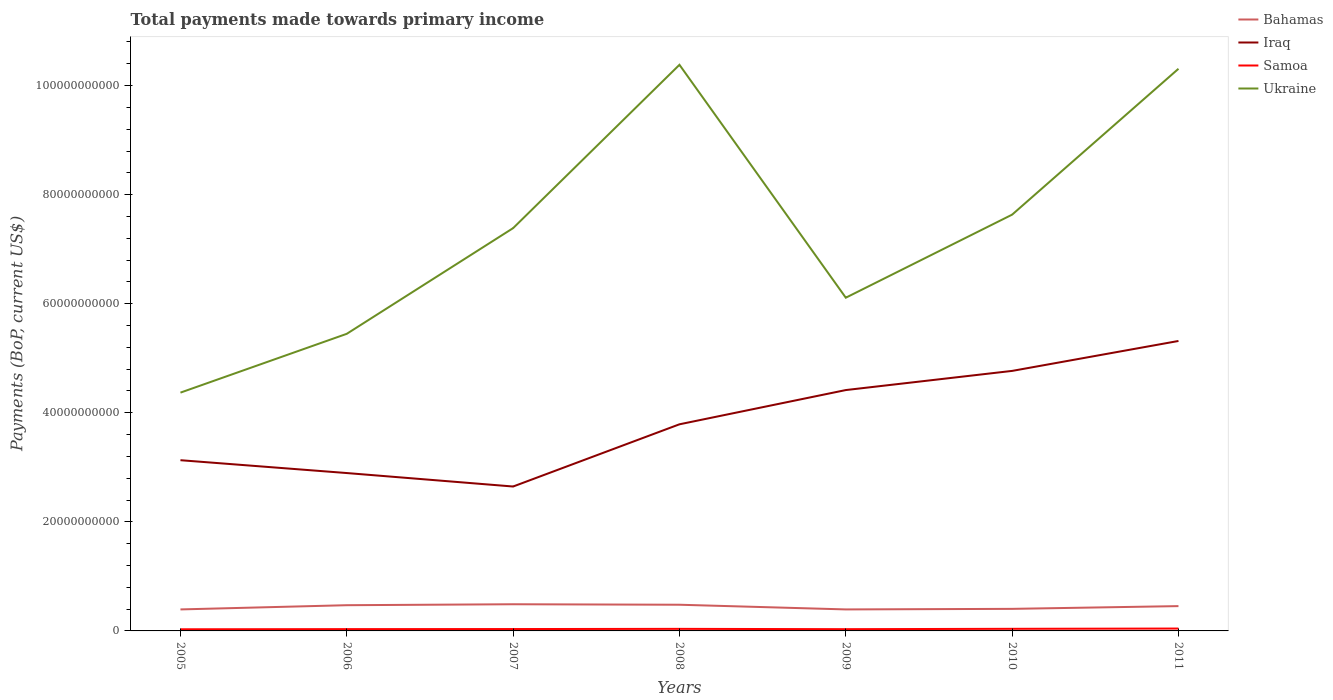Across all years, what is the maximum total payments made towards primary income in Bahamas?
Offer a terse response. 3.94e+09. In which year was the total payments made towards primary income in Iraq maximum?
Offer a very short reply. 2007. What is the total total payments made towards primary income in Bahamas in the graph?
Your answer should be compact. 9.48e+08. What is the difference between the highest and the second highest total payments made towards primary income in Samoa?
Make the answer very short. 1.34e+08. Is the total payments made towards primary income in Iraq strictly greater than the total payments made towards primary income in Samoa over the years?
Keep it short and to the point. No. How many lines are there?
Give a very brief answer. 4. How many years are there in the graph?
Your answer should be compact. 7. What is the difference between two consecutive major ticks on the Y-axis?
Make the answer very short. 2.00e+1. Are the values on the major ticks of Y-axis written in scientific E-notation?
Ensure brevity in your answer.  No. Does the graph contain grids?
Make the answer very short. No. What is the title of the graph?
Keep it short and to the point. Total payments made towards primary income. What is the label or title of the X-axis?
Make the answer very short. Years. What is the label or title of the Y-axis?
Your answer should be very brief. Payments (BoP, current US$). What is the Payments (BoP, current US$) in Bahamas in 2005?
Make the answer very short. 3.94e+09. What is the Payments (BoP, current US$) in Iraq in 2005?
Provide a short and direct response. 3.13e+1. What is the Payments (BoP, current US$) of Samoa in 2005?
Give a very brief answer. 3.00e+08. What is the Payments (BoP, current US$) in Ukraine in 2005?
Your response must be concise. 4.37e+1. What is the Payments (BoP, current US$) of Bahamas in 2006?
Offer a terse response. 4.71e+09. What is the Payments (BoP, current US$) of Iraq in 2006?
Your response must be concise. 2.89e+1. What is the Payments (BoP, current US$) in Samoa in 2006?
Offer a terse response. 3.29e+08. What is the Payments (BoP, current US$) in Ukraine in 2006?
Offer a very short reply. 5.45e+1. What is the Payments (BoP, current US$) in Bahamas in 2007?
Offer a very short reply. 4.89e+09. What is the Payments (BoP, current US$) in Iraq in 2007?
Ensure brevity in your answer.  2.65e+1. What is the Payments (BoP, current US$) of Samoa in 2007?
Your response must be concise. 3.44e+08. What is the Payments (BoP, current US$) in Ukraine in 2007?
Offer a very short reply. 7.39e+1. What is the Payments (BoP, current US$) in Bahamas in 2008?
Make the answer very short. 4.80e+09. What is the Payments (BoP, current US$) of Iraq in 2008?
Your answer should be very brief. 3.79e+1. What is the Payments (BoP, current US$) of Samoa in 2008?
Make the answer very short. 3.77e+08. What is the Payments (BoP, current US$) in Ukraine in 2008?
Keep it short and to the point. 1.04e+11. What is the Payments (BoP, current US$) in Bahamas in 2009?
Provide a short and direct response. 3.94e+09. What is the Payments (BoP, current US$) in Iraq in 2009?
Your answer should be compact. 4.42e+1. What is the Payments (BoP, current US$) in Samoa in 2009?
Keep it short and to the point. 3.20e+08. What is the Payments (BoP, current US$) in Ukraine in 2009?
Provide a succinct answer. 6.11e+1. What is the Payments (BoP, current US$) in Bahamas in 2010?
Your answer should be compact. 4.05e+09. What is the Payments (BoP, current US$) in Iraq in 2010?
Your response must be concise. 4.77e+1. What is the Payments (BoP, current US$) in Samoa in 2010?
Your answer should be compact. 3.86e+08. What is the Payments (BoP, current US$) in Ukraine in 2010?
Offer a very short reply. 7.63e+1. What is the Payments (BoP, current US$) in Bahamas in 2011?
Offer a very short reply. 4.55e+09. What is the Payments (BoP, current US$) in Iraq in 2011?
Offer a terse response. 5.32e+1. What is the Payments (BoP, current US$) in Samoa in 2011?
Ensure brevity in your answer.  4.34e+08. What is the Payments (BoP, current US$) of Ukraine in 2011?
Make the answer very short. 1.03e+11. Across all years, what is the maximum Payments (BoP, current US$) of Bahamas?
Provide a short and direct response. 4.89e+09. Across all years, what is the maximum Payments (BoP, current US$) in Iraq?
Your answer should be compact. 5.32e+1. Across all years, what is the maximum Payments (BoP, current US$) of Samoa?
Your response must be concise. 4.34e+08. Across all years, what is the maximum Payments (BoP, current US$) of Ukraine?
Offer a very short reply. 1.04e+11. Across all years, what is the minimum Payments (BoP, current US$) of Bahamas?
Make the answer very short. 3.94e+09. Across all years, what is the minimum Payments (BoP, current US$) of Iraq?
Your answer should be very brief. 2.65e+1. Across all years, what is the minimum Payments (BoP, current US$) of Samoa?
Provide a succinct answer. 3.00e+08. Across all years, what is the minimum Payments (BoP, current US$) of Ukraine?
Provide a short and direct response. 4.37e+1. What is the total Payments (BoP, current US$) of Bahamas in the graph?
Offer a very short reply. 3.09e+1. What is the total Payments (BoP, current US$) of Iraq in the graph?
Your response must be concise. 2.70e+11. What is the total Payments (BoP, current US$) in Samoa in the graph?
Ensure brevity in your answer.  2.49e+09. What is the total Payments (BoP, current US$) of Ukraine in the graph?
Ensure brevity in your answer.  5.16e+11. What is the difference between the Payments (BoP, current US$) of Bahamas in 2005 and that in 2006?
Make the answer very short. -7.72e+08. What is the difference between the Payments (BoP, current US$) of Iraq in 2005 and that in 2006?
Offer a very short reply. 2.36e+09. What is the difference between the Payments (BoP, current US$) of Samoa in 2005 and that in 2006?
Give a very brief answer. -2.86e+07. What is the difference between the Payments (BoP, current US$) of Ukraine in 2005 and that in 2006?
Ensure brevity in your answer.  -1.08e+1. What is the difference between the Payments (BoP, current US$) in Bahamas in 2005 and that in 2007?
Your answer should be very brief. -9.46e+08. What is the difference between the Payments (BoP, current US$) in Iraq in 2005 and that in 2007?
Provide a succinct answer. 4.83e+09. What is the difference between the Payments (BoP, current US$) in Samoa in 2005 and that in 2007?
Offer a terse response. -4.42e+07. What is the difference between the Payments (BoP, current US$) in Ukraine in 2005 and that in 2007?
Provide a short and direct response. -3.02e+1. What is the difference between the Payments (BoP, current US$) of Bahamas in 2005 and that in 2008?
Your response must be concise. -8.58e+08. What is the difference between the Payments (BoP, current US$) of Iraq in 2005 and that in 2008?
Provide a short and direct response. -6.58e+09. What is the difference between the Payments (BoP, current US$) in Samoa in 2005 and that in 2008?
Offer a very short reply. -7.67e+07. What is the difference between the Payments (BoP, current US$) in Ukraine in 2005 and that in 2008?
Keep it short and to the point. -6.01e+1. What is the difference between the Payments (BoP, current US$) in Bahamas in 2005 and that in 2009?
Your answer should be compact. 1.18e+06. What is the difference between the Payments (BoP, current US$) in Iraq in 2005 and that in 2009?
Offer a very short reply. -1.29e+1. What is the difference between the Payments (BoP, current US$) in Samoa in 2005 and that in 2009?
Your answer should be compact. -1.96e+07. What is the difference between the Payments (BoP, current US$) in Ukraine in 2005 and that in 2009?
Provide a short and direct response. -1.74e+1. What is the difference between the Payments (BoP, current US$) of Bahamas in 2005 and that in 2010?
Make the answer very short. -1.03e+08. What is the difference between the Payments (BoP, current US$) of Iraq in 2005 and that in 2010?
Give a very brief answer. -1.64e+1. What is the difference between the Payments (BoP, current US$) in Samoa in 2005 and that in 2010?
Your answer should be very brief. -8.62e+07. What is the difference between the Payments (BoP, current US$) of Ukraine in 2005 and that in 2010?
Your answer should be compact. -3.26e+1. What is the difference between the Payments (BoP, current US$) in Bahamas in 2005 and that in 2011?
Offer a very short reply. -6.07e+08. What is the difference between the Payments (BoP, current US$) in Iraq in 2005 and that in 2011?
Offer a terse response. -2.19e+1. What is the difference between the Payments (BoP, current US$) in Samoa in 2005 and that in 2011?
Your response must be concise. -1.34e+08. What is the difference between the Payments (BoP, current US$) of Ukraine in 2005 and that in 2011?
Offer a terse response. -5.94e+1. What is the difference between the Payments (BoP, current US$) of Bahamas in 2006 and that in 2007?
Offer a very short reply. -1.75e+08. What is the difference between the Payments (BoP, current US$) of Iraq in 2006 and that in 2007?
Give a very brief answer. 2.47e+09. What is the difference between the Payments (BoP, current US$) in Samoa in 2006 and that in 2007?
Your answer should be compact. -1.56e+07. What is the difference between the Payments (BoP, current US$) of Ukraine in 2006 and that in 2007?
Your response must be concise. -1.94e+1. What is the difference between the Payments (BoP, current US$) of Bahamas in 2006 and that in 2008?
Ensure brevity in your answer.  -8.58e+07. What is the difference between the Payments (BoP, current US$) of Iraq in 2006 and that in 2008?
Keep it short and to the point. -8.94e+09. What is the difference between the Payments (BoP, current US$) of Samoa in 2006 and that in 2008?
Make the answer very short. -4.81e+07. What is the difference between the Payments (BoP, current US$) of Ukraine in 2006 and that in 2008?
Provide a short and direct response. -4.93e+1. What is the difference between the Payments (BoP, current US$) in Bahamas in 2006 and that in 2009?
Keep it short and to the point. 7.73e+08. What is the difference between the Payments (BoP, current US$) in Iraq in 2006 and that in 2009?
Give a very brief answer. -1.52e+1. What is the difference between the Payments (BoP, current US$) in Samoa in 2006 and that in 2009?
Give a very brief answer. 8.97e+06. What is the difference between the Payments (BoP, current US$) of Ukraine in 2006 and that in 2009?
Your answer should be very brief. -6.62e+09. What is the difference between the Payments (BoP, current US$) in Bahamas in 2006 and that in 2010?
Provide a succinct answer. 6.69e+08. What is the difference between the Payments (BoP, current US$) in Iraq in 2006 and that in 2010?
Your response must be concise. -1.87e+1. What is the difference between the Payments (BoP, current US$) of Samoa in 2006 and that in 2010?
Give a very brief answer. -5.76e+07. What is the difference between the Payments (BoP, current US$) in Ukraine in 2006 and that in 2010?
Offer a very short reply. -2.19e+1. What is the difference between the Payments (BoP, current US$) in Bahamas in 2006 and that in 2011?
Your answer should be very brief. 1.65e+08. What is the difference between the Payments (BoP, current US$) in Iraq in 2006 and that in 2011?
Your answer should be very brief. -2.42e+1. What is the difference between the Payments (BoP, current US$) of Samoa in 2006 and that in 2011?
Ensure brevity in your answer.  -1.05e+08. What is the difference between the Payments (BoP, current US$) of Ukraine in 2006 and that in 2011?
Keep it short and to the point. -4.86e+1. What is the difference between the Payments (BoP, current US$) in Bahamas in 2007 and that in 2008?
Provide a succinct answer. 8.88e+07. What is the difference between the Payments (BoP, current US$) in Iraq in 2007 and that in 2008?
Your answer should be compact. -1.14e+1. What is the difference between the Payments (BoP, current US$) in Samoa in 2007 and that in 2008?
Your answer should be very brief. -3.25e+07. What is the difference between the Payments (BoP, current US$) of Ukraine in 2007 and that in 2008?
Keep it short and to the point. -2.99e+1. What is the difference between the Payments (BoP, current US$) in Bahamas in 2007 and that in 2009?
Provide a short and direct response. 9.48e+08. What is the difference between the Payments (BoP, current US$) of Iraq in 2007 and that in 2009?
Your answer should be compact. -1.77e+1. What is the difference between the Payments (BoP, current US$) of Samoa in 2007 and that in 2009?
Your answer should be very brief. 2.46e+07. What is the difference between the Payments (BoP, current US$) in Ukraine in 2007 and that in 2009?
Offer a terse response. 1.28e+1. What is the difference between the Payments (BoP, current US$) of Bahamas in 2007 and that in 2010?
Make the answer very short. 8.43e+08. What is the difference between the Payments (BoP, current US$) in Iraq in 2007 and that in 2010?
Make the answer very short. -2.12e+1. What is the difference between the Payments (BoP, current US$) of Samoa in 2007 and that in 2010?
Offer a very short reply. -4.20e+07. What is the difference between the Payments (BoP, current US$) in Ukraine in 2007 and that in 2010?
Keep it short and to the point. -2.47e+09. What is the difference between the Payments (BoP, current US$) of Bahamas in 2007 and that in 2011?
Offer a very short reply. 3.40e+08. What is the difference between the Payments (BoP, current US$) of Iraq in 2007 and that in 2011?
Your answer should be very brief. -2.67e+1. What is the difference between the Payments (BoP, current US$) of Samoa in 2007 and that in 2011?
Provide a succinct answer. -8.98e+07. What is the difference between the Payments (BoP, current US$) in Ukraine in 2007 and that in 2011?
Keep it short and to the point. -2.92e+1. What is the difference between the Payments (BoP, current US$) of Bahamas in 2008 and that in 2009?
Offer a terse response. 8.59e+08. What is the difference between the Payments (BoP, current US$) of Iraq in 2008 and that in 2009?
Your response must be concise. -6.28e+09. What is the difference between the Payments (BoP, current US$) in Samoa in 2008 and that in 2009?
Your answer should be very brief. 5.70e+07. What is the difference between the Payments (BoP, current US$) of Ukraine in 2008 and that in 2009?
Your answer should be very brief. 4.27e+1. What is the difference between the Payments (BoP, current US$) in Bahamas in 2008 and that in 2010?
Give a very brief answer. 7.54e+08. What is the difference between the Payments (BoP, current US$) in Iraq in 2008 and that in 2010?
Make the answer very short. -9.79e+09. What is the difference between the Payments (BoP, current US$) in Samoa in 2008 and that in 2010?
Your answer should be compact. -9.55e+06. What is the difference between the Payments (BoP, current US$) in Ukraine in 2008 and that in 2010?
Keep it short and to the point. 2.75e+1. What is the difference between the Payments (BoP, current US$) of Bahamas in 2008 and that in 2011?
Provide a succinct answer. 2.51e+08. What is the difference between the Payments (BoP, current US$) of Iraq in 2008 and that in 2011?
Provide a short and direct response. -1.53e+1. What is the difference between the Payments (BoP, current US$) of Samoa in 2008 and that in 2011?
Your response must be concise. -5.74e+07. What is the difference between the Payments (BoP, current US$) of Ukraine in 2008 and that in 2011?
Offer a very short reply. 7.29e+08. What is the difference between the Payments (BoP, current US$) of Bahamas in 2009 and that in 2010?
Give a very brief answer. -1.05e+08. What is the difference between the Payments (BoP, current US$) of Iraq in 2009 and that in 2010?
Your response must be concise. -3.51e+09. What is the difference between the Payments (BoP, current US$) of Samoa in 2009 and that in 2010?
Your answer should be very brief. -6.66e+07. What is the difference between the Payments (BoP, current US$) of Ukraine in 2009 and that in 2010?
Your response must be concise. -1.52e+1. What is the difference between the Payments (BoP, current US$) of Bahamas in 2009 and that in 2011?
Make the answer very short. -6.08e+08. What is the difference between the Payments (BoP, current US$) in Iraq in 2009 and that in 2011?
Offer a very short reply. -9.00e+09. What is the difference between the Payments (BoP, current US$) of Samoa in 2009 and that in 2011?
Give a very brief answer. -1.14e+08. What is the difference between the Payments (BoP, current US$) of Ukraine in 2009 and that in 2011?
Offer a terse response. -4.20e+1. What is the difference between the Payments (BoP, current US$) in Bahamas in 2010 and that in 2011?
Keep it short and to the point. -5.03e+08. What is the difference between the Payments (BoP, current US$) in Iraq in 2010 and that in 2011?
Provide a succinct answer. -5.49e+09. What is the difference between the Payments (BoP, current US$) in Samoa in 2010 and that in 2011?
Your answer should be compact. -4.78e+07. What is the difference between the Payments (BoP, current US$) in Ukraine in 2010 and that in 2011?
Offer a very short reply. -2.67e+1. What is the difference between the Payments (BoP, current US$) of Bahamas in 2005 and the Payments (BoP, current US$) of Iraq in 2006?
Keep it short and to the point. -2.50e+1. What is the difference between the Payments (BoP, current US$) of Bahamas in 2005 and the Payments (BoP, current US$) of Samoa in 2006?
Provide a succinct answer. 3.61e+09. What is the difference between the Payments (BoP, current US$) of Bahamas in 2005 and the Payments (BoP, current US$) of Ukraine in 2006?
Keep it short and to the point. -5.05e+1. What is the difference between the Payments (BoP, current US$) of Iraq in 2005 and the Payments (BoP, current US$) of Samoa in 2006?
Make the answer very short. 3.10e+1. What is the difference between the Payments (BoP, current US$) of Iraq in 2005 and the Payments (BoP, current US$) of Ukraine in 2006?
Your response must be concise. -2.32e+1. What is the difference between the Payments (BoP, current US$) in Samoa in 2005 and the Payments (BoP, current US$) in Ukraine in 2006?
Your answer should be very brief. -5.42e+1. What is the difference between the Payments (BoP, current US$) in Bahamas in 2005 and the Payments (BoP, current US$) in Iraq in 2007?
Provide a short and direct response. -2.25e+1. What is the difference between the Payments (BoP, current US$) of Bahamas in 2005 and the Payments (BoP, current US$) of Samoa in 2007?
Ensure brevity in your answer.  3.60e+09. What is the difference between the Payments (BoP, current US$) of Bahamas in 2005 and the Payments (BoP, current US$) of Ukraine in 2007?
Make the answer very short. -6.99e+1. What is the difference between the Payments (BoP, current US$) of Iraq in 2005 and the Payments (BoP, current US$) of Samoa in 2007?
Keep it short and to the point. 3.10e+1. What is the difference between the Payments (BoP, current US$) in Iraq in 2005 and the Payments (BoP, current US$) in Ukraine in 2007?
Offer a terse response. -4.26e+1. What is the difference between the Payments (BoP, current US$) in Samoa in 2005 and the Payments (BoP, current US$) in Ukraine in 2007?
Your answer should be very brief. -7.36e+1. What is the difference between the Payments (BoP, current US$) in Bahamas in 2005 and the Payments (BoP, current US$) in Iraq in 2008?
Your response must be concise. -3.39e+1. What is the difference between the Payments (BoP, current US$) in Bahamas in 2005 and the Payments (BoP, current US$) in Samoa in 2008?
Your response must be concise. 3.57e+09. What is the difference between the Payments (BoP, current US$) in Bahamas in 2005 and the Payments (BoP, current US$) in Ukraine in 2008?
Ensure brevity in your answer.  -9.99e+1. What is the difference between the Payments (BoP, current US$) in Iraq in 2005 and the Payments (BoP, current US$) in Samoa in 2008?
Give a very brief answer. 3.09e+1. What is the difference between the Payments (BoP, current US$) in Iraq in 2005 and the Payments (BoP, current US$) in Ukraine in 2008?
Offer a very short reply. -7.25e+1. What is the difference between the Payments (BoP, current US$) of Samoa in 2005 and the Payments (BoP, current US$) of Ukraine in 2008?
Give a very brief answer. -1.04e+11. What is the difference between the Payments (BoP, current US$) in Bahamas in 2005 and the Payments (BoP, current US$) in Iraq in 2009?
Keep it short and to the point. -4.02e+1. What is the difference between the Payments (BoP, current US$) in Bahamas in 2005 and the Payments (BoP, current US$) in Samoa in 2009?
Your answer should be very brief. 3.62e+09. What is the difference between the Payments (BoP, current US$) of Bahamas in 2005 and the Payments (BoP, current US$) of Ukraine in 2009?
Provide a short and direct response. -5.72e+1. What is the difference between the Payments (BoP, current US$) in Iraq in 2005 and the Payments (BoP, current US$) in Samoa in 2009?
Offer a very short reply. 3.10e+1. What is the difference between the Payments (BoP, current US$) of Iraq in 2005 and the Payments (BoP, current US$) of Ukraine in 2009?
Make the answer very short. -2.98e+1. What is the difference between the Payments (BoP, current US$) of Samoa in 2005 and the Payments (BoP, current US$) of Ukraine in 2009?
Provide a succinct answer. -6.08e+1. What is the difference between the Payments (BoP, current US$) in Bahamas in 2005 and the Payments (BoP, current US$) in Iraq in 2010?
Your answer should be compact. -4.37e+1. What is the difference between the Payments (BoP, current US$) of Bahamas in 2005 and the Payments (BoP, current US$) of Samoa in 2010?
Ensure brevity in your answer.  3.56e+09. What is the difference between the Payments (BoP, current US$) of Bahamas in 2005 and the Payments (BoP, current US$) of Ukraine in 2010?
Keep it short and to the point. -7.24e+1. What is the difference between the Payments (BoP, current US$) of Iraq in 2005 and the Payments (BoP, current US$) of Samoa in 2010?
Offer a very short reply. 3.09e+1. What is the difference between the Payments (BoP, current US$) of Iraq in 2005 and the Payments (BoP, current US$) of Ukraine in 2010?
Your response must be concise. -4.50e+1. What is the difference between the Payments (BoP, current US$) in Samoa in 2005 and the Payments (BoP, current US$) in Ukraine in 2010?
Offer a very short reply. -7.60e+1. What is the difference between the Payments (BoP, current US$) in Bahamas in 2005 and the Payments (BoP, current US$) in Iraq in 2011?
Give a very brief answer. -4.92e+1. What is the difference between the Payments (BoP, current US$) in Bahamas in 2005 and the Payments (BoP, current US$) in Samoa in 2011?
Provide a succinct answer. 3.51e+09. What is the difference between the Payments (BoP, current US$) in Bahamas in 2005 and the Payments (BoP, current US$) in Ukraine in 2011?
Provide a succinct answer. -9.91e+1. What is the difference between the Payments (BoP, current US$) in Iraq in 2005 and the Payments (BoP, current US$) in Samoa in 2011?
Make the answer very short. 3.09e+1. What is the difference between the Payments (BoP, current US$) in Iraq in 2005 and the Payments (BoP, current US$) in Ukraine in 2011?
Offer a terse response. -7.18e+1. What is the difference between the Payments (BoP, current US$) of Samoa in 2005 and the Payments (BoP, current US$) of Ukraine in 2011?
Make the answer very short. -1.03e+11. What is the difference between the Payments (BoP, current US$) of Bahamas in 2006 and the Payments (BoP, current US$) of Iraq in 2007?
Keep it short and to the point. -2.18e+1. What is the difference between the Payments (BoP, current US$) in Bahamas in 2006 and the Payments (BoP, current US$) in Samoa in 2007?
Offer a very short reply. 4.37e+09. What is the difference between the Payments (BoP, current US$) in Bahamas in 2006 and the Payments (BoP, current US$) in Ukraine in 2007?
Offer a terse response. -6.91e+1. What is the difference between the Payments (BoP, current US$) of Iraq in 2006 and the Payments (BoP, current US$) of Samoa in 2007?
Ensure brevity in your answer.  2.86e+1. What is the difference between the Payments (BoP, current US$) in Iraq in 2006 and the Payments (BoP, current US$) in Ukraine in 2007?
Offer a very short reply. -4.49e+1. What is the difference between the Payments (BoP, current US$) in Samoa in 2006 and the Payments (BoP, current US$) in Ukraine in 2007?
Offer a very short reply. -7.35e+1. What is the difference between the Payments (BoP, current US$) in Bahamas in 2006 and the Payments (BoP, current US$) in Iraq in 2008?
Your answer should be compact. -3.32e+1. What is the difference between the Payments (BoP, current US$) of Bahamas in 2006 and the Payments (BoP, current US$) of Samoa in 2008?
Provide a short and direct response. 4.34e+09. What is the difference between the Payments (BoP, current US$) of Bahamas in 2006 and the Payments (BoP, current US$) of Ukraine in 2008?
Offer a terse response. -9.91e+1. What is the difference between the Payments (BoP, current US$) of Iraq in 2006 and the Payments (BoP, current US$) of Samoa in 2008?
Offer a terse response. 2.86e+1. What is the difference between the Payments (BoP, current US$) of Iraq in 2006 and the Payments (BoP, current US$) of Ukraine in 2008?
Keep it short and to the point. -7.49e+1. What is the difference between the Payments (BoP, current US$) of Samoa in 2006 and the Payments (BoP, current US$) of Ukraine in 2008?
Give a very brief answer. -1.03e+11. What is the difference between the Payments (BoP, current US$) of Bahamas in 2006 and the Payments (BoP, current US$) of Iraq in 2009?
Give a very brief answer. -3.95e+1. What is the difference between the Payments (BoP, current US$) in Bahamas in 2006 and the Payments (BoP, current US$) in Samoa in 2009?
Your response must be concise. 4.39e+09. What is the difference between the Payments (BoP, current US$) of Bahamas in 2006 and the Payments (BoP, current US$) of Ukraine in 2009?
Make the answer very short. -5.64e+1. What is the difference between the Payments (BoP, current US$) in Iraq in 2006 and the Payments (BoP, current US$) in Samoa in 2009?
Keep it short and to the point. 2.86e+1. What is the difference between the Payments (BoP, current US$) of Iraq in 2006 and the Payments (BoP, current US$) of Ukraine in 2009?
Offer a terse response. -3.22e+1. What is the difference between the Payments (BoP, current US$) of Samoa in 2006 and the Payments (BoP, current US$) of Ukraine in 2009?
Offer a terse response. -6.08e+1. What is the difference between the Payments (BoP, current US$) of Bahamas in 2006 and the Payments (BoP, current US$) of Iraq in 2010?
Give a very brief answer. -4.30e+1. What is the difference between the Payments (BoP, current US$) in Bahamas in 2006 and the Payments (BoP, current US$) in Samoa in 2010?
Keep it short and to the point. 4.33e+09. What is the difference between the Payments (BoP, current US$) in Bahamas in 2006 and the Payments (BoP, current US$) in Ukraine in 2010?
Make the answer very short. -7.16e+1. What is the difference between the Payments (BoP, current US$) of Iraq in 2006 and the Payments (BoP, current US$) of Samoa in 2010?
Your answer should be compact. 2.86e+1. What is the difference between the Payments (BoP, current US$) of Iraq in 2006 and the Payments (BoP, current US$) of Ukraine in 2010?
Provide a succinct answer. -4.74e+1. What is the difference between the Payments (BoP, current US$) in Samoa in 2006 and the Payments (BoP, current US$) in Ukraine in 2010?
Your answer should be very brief. -7.60e+1. What is the difference between the Payments (BoP, current US$) of Bahamas in 2006 and the Payments (BoP, current US$) of Iraq in 2011?
Keep it short and to the point. -4.85e+1. What is the difference between the Payments (BoP, current US$) of Bahamas in 2006 and the Payments (BoP, current US$) of Samoa in 2011?
Provide a short and direct response. 4.28e+09. What is the difference between the Payments (BoP, current US$) in Bahamas in 2006 and the Payments (BoP, current US$) in Ukraine in 2011?
Your response must be concise. -9.84e+1. What is the difference between the Payments (BoP, current US$) in Iraq in 2006 and the Payments (BoP, current US$) in Samoa in 2011?
Give a very brief answer. 2.85e+1. What is the difference between the Payments (BoP, current US$) of Iraq in 2006 and the Payments (BoP, current US$) of Ukraine in 2011?
Give a very brief answer. -7.41e+1. What is the difference between the Payments (BoP, current US$) in Samoa in 2006 and the Payments (BoP, current US$) in Ukraine in 2011?
Keep it short and to the point. -1.03e+11. What is the difference between the Payments (BoP, current US$) of Bahamas in 2007 and the Payments (BoP, current US$) of Iraq in 2008?
Ensure brevity in your answer.  -3.30e+1. What is the difference between the Payments (BoP, current US$) of Bahamas in 2007 and the Payments (BoP, current US$) of Samoa in 2008?
Make the answer very short. 4.51e+09. What is the difference between the Payments (BoP, current US$) of Bahamas in 2007 and the Payments (BoP, current US$) of Ukraine in 2008?
Provide a succinct answer. -9.89e+1. What is the difference between the Payments (BoP, current US$) of Iraq in 2007 and the Payments (BoP, current US$) of Samoa in 2008?
Ensure brevity in your answer.  2.61e+1. What is the difference between the Payments (BoP, current US$) of Iraq in 2007 and the Payments (BoP, current US$) of Ukraine in 2008?
Keep it short and to the point. -7.73e+1. What is the difference between the Payments (BoP, current US$) of Samoa in 2007 and the Payments (BoP, current US$) of Ukraine in 2008?
Keep it short and to the point. -1.03e+11. What is the difference between the Payments (BoP, current US$) in Bahamas in 2007 and the Payments (BoP, current US$) in Iraq in 2009?
Ensure brevity in your answer.  -3.93e+1. What is the difference between the Payments (BoP, current US$) of Bahamas in 2007 and the Payments (BoP, current US$) of Samoa in 2009?
Ensure brevity in your answer.  4.57e+09. What is the difference between the Payments (BoP, current US$) in Bahamas in 2007 and the Payments (BoP, current US$) in Ukraine in 2009?
Ensure brevity in your answer.  -5.62e+1. What is the difference between the Payments (BoP, current US$) in Iraq in 2007 and the Payments (BoP, current US$) in Samoa in 2009?
Offer a very short reply. 2.62e+1. What is the difference between the Payments (BoP, current US$) in Iraq in 2007 and the Payments (BoP, current US$) in Ukraine in 2009?
Your answer should be compact. -3.46e+1. What is the difference between the Payments (BoP, current US$) in Samoa in 2007 and the Payments (BoP, current US$) in Ukraine in 2009?
Ensure brevity in your answer.  -6.08e+1. What is the difference between the Payments (BoP, current US$) of Bahamas in 2007 and the Payments (BoP, current US$) of Iraq in 2010?
Your response must be concise. -4.28e+1. What is the difference between the Payments (BoP, current US$) of Bahamas in 2007 and the Payments (BoP, current US$) of Samoa in 2010?
Your response must be concise. 4.50e+09. What is the difference between the Payments (BoP, current US$) of Bahamas in 2007 and the Payments (BoP, current US$) of Ukraine in 2010?
Keep it short and to the point. -7.14e+1. What is the difference between the Payments (BoP, current US$) of Iraq in 2007 and the Payments (BoP, current US$) of Samoa in 2010?
Your response must be concise. 2.61e+1. What is the difference between the Payments (BoP, current US$) of Iraq in 2007 and the Payments (BoP, current US$) of Ukraine in 2010?
Your answer should be very brief. -4.99e+1. What is the difference between the Payments (BoP, current US$) in Samoa in 2007 and the Payments (BoP, current US$) in Ukraine in 2010?
Give a very brief answer. -7.60e+1. What is the difference between the Payments (BoP, current US$) of Bahamas in 2007 and the Payments (BoP, current US$) of Iraq in 2011?
Offer a very short reply. -4.83e+1. What is the difference between the Payments (BoP, current US$) in Bahamas in 2007 and the Payments (BoP, current US$) in Samoa in 2011?
Your response must be concise. 4.46e+09. What is the difference between the Payments (BoP, current US$) in Bahamas in 2007 and the Payments (BoP, current US$) in Ukraine in 2011?
Provide a succinct answer. -9.82e+1. What is the difference between the Payments (BoP, current US$) in Iraq in 2007 and the Payments (BoP, current US$) in Samoa in 2011?
Your answer should be very brief. 2.60e+1. What is the difference between the Payments (BoP, current US$) of Iraq in 2007 and the Payments (BoP, current US$) of Ukraine in 2011?
Give a very brief answer. -7.66e+1. What is the difference between the Payments (BoP, current US$) of Samoa in 2007 and the Payments (BoP, current US$) of Ukraine in 2011?
Your answer should be compact. -1.03e+11. What is the difference between the Payments (BoP, current US$) in Bahamas in 2008 and the Payments (BoP, current US$) in Iraq in 2009?
Your answer should be compact. -3.94e+1. What is the difference between the Payments (BoP, current US$) in Bahamas in 2008 and the Payments (BoP, current US$) in Samoa in 2009?
Ensure brevity in your answer.  4.48e+09. What is the difference between the Payments (BoP, current US$) in Bahamas in 2008 and the Payments (BoP, current US$) in Ukraine in 2009?
Keep it short and to the point. -5.63e+1. What is the difference between the Payments (BoP, current US$) of Iraq in 2008 and the Payments (BoP, current US$) of Samoa in 2009?
Your answer should be very brief. 3.76e+1. What is the difference between the Payments (BoP, current US$) of Iraq in 2008 and the Payments (BoP, current US$) of Ukraine in 2009?
Provide a short and direct response. -2.32e+1. What is the difference between the Payments (BoP, current US$) of Samoa in 2008 and the Payments (BoP, current US$) of Ukraine in 2009?
Your answer should be very brief. -6.07e+1. What is the difference between the Payments (BoP, current US$) of Bahamas in 2008 and the Payments (BoP, current US$) of Iraq in 2010?
Offer a very short reply. -4.29e+1. What is the difference between the Payments (BoP, current US$) in Bahamas in 2008 and the Payments (BoP, current US$) in Samoa in 2010?
Your answer should be very brief. 4.41e+09. What is the difference between the Payments (BoP, current US$) in Bahamas in 2008 and the Payments (BoP, current US$) in Ukraine in 2010?
Give a very brief answer. -7.15e+1. What is the difference between the Payments (BoP, current US$) of Iraq in 2008 and the Payments (BoP, current US$) of Samoa in 2010?
Your response must be concise. 3.75e+1. What is the difference between the Payments (BoP, current US$) in Iraq in 2008 and the Payments (BoP, current US$) in Ukraine in 2010?
Your answer should be compact. -3.84e+1. What is the difference between the Payments (BoP, current US$) of Samoa in 2008 and the Payments (BoP, current US$) of Ukraine in 2010?
Your answer should be very brief. -7.60e+1. What is the difference between the Payments (BoP, current US$) of Bahamas in 2008 and the Payments (BoP, current US$) of Iraq in 2011?
Make the answer very short. -4.84e+1. What is the difference between the Payments (BoP, current US$) of Bahamas in 2008 and the Payments (BoP, current US$) of Samoa in 2011?
Your answer should be compact. 4.37e+09. What is the difference between the Payments (BoP, current US$) of Bahamas in 2008 and the Payments (BoP, current US$) of Ukraine in 2011?
Offer a very short reply. -9.83e+1. What is the difference between the Payments (BoP, current US$) in Iraq in 2008 and the Payments (BoP, current US$) in Samoa in 2011?
Give a very brief answer. 3.75e+1. What is the difference between the Payments (BoP, current US$) of Iraq in 2008 and the Payments (BoP, current US$) of Ukraine in 2011?
Provide a short and direct response. -6.52e+1. What is the difference between the Payments (BoP, current US$) of Samoa in 2008 and the Payments (BoP, current US$) of Ukraine in 2011?
Your response must be concise. -1.03e+11. What is the difference between the Payments (BoP, current US$) of Bahamas in 2009 and the Payments (BoP, current US$) of Iraq in 2010?
Offer a very short reply. -4.37e+1. What is the difference between the Payments (BoP, current US$) in Bahamas in 2009 and the Payments (BoP, current US$) in Samoa in 2010?
Offer a terse response. 3.56e+09. What is the difference between the Payments (BoP, current US$) of Bahamas in 2009 and the Payments (BoP, current US$) of Ukraine in 2010?
Keep it short and to the point. -7.24e+1. What is the difference between the Payments (BoP, current US$) of Iraq in 2009 and the Payments (BoP, current US$) of Samoa in 2010?
Keep it short and to the point. 4.38e+1. What is the difference between the Payments (BoP, current US$) of Iraq in 2009 and the Payments (BoP, current US$) of Ukraine in 2010?
Your answer should be very brief. -3.22e+1. What is the difference between the Payments (BoP, current US$) in Samoa in 2009 and the Payments (BoP, current US$) in Ukraine in 2010?
Your answer should be compact. -7.60e+1. What is the difference between the Payments (BoP, current US$) of Bahamas in 2009 and the Payments (BoP, current US$) of Iraq in 2011?
Your answer should be very brief. -4.92e+1. What is the difference between the Payments (BoP, current US$) in Bahamas in 2009 and the Payments (BoP, current US$) in Samoa in 2011?
Keep it short and to the point. 3.51e+09. What is the difference between the Payments (BoP, current US$) in Bahamas in 2009 and the Payments (BoP, current US$) in Ukraine in 2011?
Give a very brief answer. -9.91e+1. What is the difference between the Payments (BoP, current US$) of Iraq in 2009 and the Payments (BoP, current US$) of Samoa in 2011?
Give a very brief answer. 4.37e+1. What is the difference between the Payments (BoP, current US$) of Iraq in 2009 and the Payments (BoP, current US$) of Ukraine in 2011?
Ensure brevity in your answer.  -5.89e+1. What is the difference between the Payments (BoP, current US$) in Samoa in 2009 and the Payments (BoP, current US$) in Ukraine in 2011?
Offer a very short reply. -1.03e+11. What is the difference between the Payments (BoP, current US$) of Bahamas in 2010 and the Payments (BoP, current US$) of Iraq in 2011?
Your response must be concise. -4.91e+1. What is the difference between the Payments (BoP, current US$) of Bahamas in 2010 and the Payments (BoP, current US$) of Samoa in 2011?
Offer a terse response. 3.61e+09. What is the difference between the Payments (BoP, current US$) in Bahamas in 2010 and the Payments (BoP, current US$) in Ukraine in 2011?
Your answer should be very brief. -9.90e+1. What is the difference between the Payments (BoP, current US$) of Iraq in 2010 and the Payments (BoP, current US$) of Samoa in 2011?
Ensure brevity in your answer.  4.72e+1. What is the difference between the Payments (BoP, current US$) in Iraq in 2010 and the Payments (BoP, current US$) in Ukraine in 2011?
Your answer should be compact. -5.54e+1. What is the difference between the Payments (BoP, current US$) in Samoa in 2010 and the Payments (BoP, current US$) in Ukraine in 2011?
Provide a short and direct response. -1.03e+11. What is the average Payments (BoP, current US$) in Bahamas per year?
Keep it short and to the point. 4.41e+09. What is the average Payments (BoP, current US$) of Iraq per year?
Give a very brief answer. 3.85e+1. What is the average Payments (BoP, current US$) of Samoa per year?
Your answer should be compact. 3.56e+08. What is the average Payments (BoP, current US$) in Ukraine per year?
Offer a very short reply. 7.38e+1. In the year 2005, what is the difference between the Payments (BoP, current US$) of Bahamas and Payments (BoP, current US$) of Iraq?
Keep it short and to the point. -2.74e+1. In the year 2005, what is the difference between the Payments (BoP, current US$) of Bahamas and Payments (BoP, current US$) of Samoa?
Give a very brief answer. 3.64e+09. In the year 2005, what is the difference between the Payments (BoP, current US$) of Bahamas and Payments (BoP, current US$) of Ukraine?
Provide a succinct answer. -3.98e+1. In the year 2005, what is the difference between the Payments (BoP, current US$) in Iraq and Payments (BoP, current US$) in Samoa?
Ensure brevity in your answer.  3.10e+1. In the year 2005, what is the difference between the Payments (BoP, current US$) of Iraq and Payments (BoP, current US$) of Ukraine?
Keep it short and to the point. -1.24e+1. In the year 2005, what is the difference between the Payments (BoP, current US$) of Samoa and Payments (BoP, current US$) of Ukraine?
Ensure brevity in your answer.  -4.34e+1. In the year 2006, what is the difference between the Payments (BoP, current US$) in Bahamas and Payments (BoP, current US$) in Iraq?
Provide a short and direct response. -2.42e+1. In the year 2006, what is the difference between the Payments (BoP, current US$) in Bahamas and Payments (BoP, current US$) in Samoa?
Give a very brief answer. 4.39e+09. In the year 2006, what is the difference between the Payments (BoP, current US$) of Bahamas and Payments (BoP, current US$) of Ukraine?
Your response must be concise. -4.98e+1. In the year 2006, what is the difference between the Payments (BoP, current US$) in Iraq and Payments (BoP, current US$) in Samoa?
Your answer should be very brief. 2.86e+1. In the year 2006, what is the difference between the Payments (BoP, current US$) of Iraq and Payments (BoP, current US$) of Ukraine?
Provide a succinct answer. -2.55e+1. In the year 2006, what is the difference between the Payments (BoP, current US$) of Samoa and Payments (BoP, current US$) of Ukraine?
Ensure brevity in your answer.  -5.42e+1. In the year 2007, what is the difference between the Payments (BoP, current US$) in Bahamas and Payments (BoP, current US$) in Iraq?
Provide a succinct answer. -2.16e+1. In the year 2007, what is the difference between the Payments (BoP, current US$) in Bahamas and Payments (BoP, current US$) in Samoa?
Provide a succinct answer. 4.55e+09. In the year 2007, what is the difference between the Payments (BoP, current US$) of Bahamas and Payments (BoP, current US$) of Ukraine?
Give a very brief answer. -6.90e+1. In the year 2007, what is the difference between the Payments (BoP, current US$) in Iraq and Payments (BoP, current US$) in Samoa?
Your response must be concise. 2.61e+1. In the year 2007, what is the difference between the Payments (BoP, current US$) in Iraq and Payments (BoP, current US$) in Ukraine?
Offer a terse response. -4.74e+1. In the year 2007, what is the difference between the Payments (BoP, current US$) of Samoa and Payments (BoP, current US$) of Ukraine?
Provide a short and direct response. -7.35e+1. In the year 2008, what is the difference between the Payments (BoP, current US$) in Bahamas and Payments (BoP, current US$) in Iraq?
Your answer should be compact. -3.31e+1. In the year 2008, what is the difference between the Payments (BoP, current US$) in Bahamas and Payments (BoP, current US$) in Samoa?
Provide a succinct answer. 4.42e+09. In the year 2008, what is the difference between the Payments (BoP, current US$) of Bahamas and Payments (BoP, current US$) of Ukraine?
Offer a very short reply. -9.90e+1. In the year 2008, what is the difference between the Payments (BoP, current US$) in Iraq and Payments (BoP, current US$) in Samoa?
Your answer should be very brief. 3.75e+1. In the year 2008, what is the difference between the Payments (BoP, current US$) in Iraq and Payments (BoP, current US$) in Ukraine?
Ensure brevity in your answer.  -6.59e+1. In the year 2008, what is the difference between the Payments (BoP, current US$) in Samoa and Payments (BoP, current US$) in Ukraine?
Provide a succinct answer. -1.03e+11. In the year 2009, what is the difference between the Payments (BoP, current US$) of Bahamas and Payments (BoP, current US$) of Iraq?
Give a very brief answer. -4.02e+1. In the year 2009, what is the difference between the Payments (BoP, current US$) in Bahamas and Payments (BoP, current US$) in Samoa?
Keep it short and to the point. 3.62e+09. In the year 2009, what is the difference between the Payments (BoP, current US$) of Bahamas and Payments (BoP, current US$) of Ukraine?
Offer a terse response. -5.72e+1. In the year 2009, what is the difference between the Payments (BoP, current US$) of Iraq and Payments (BoP, current US$) of Samoa?
Your response must be concise. 4.38e+1. In the year 2009, what is the difference between the Payments (BoP, current US$) of Iraq and Payments (BoP, current US$) of Ukraine?
Ensure brevity in your answer.  -1.69e+1. In the year 2009, what is the difference between the Payments (BoP, current US$) in Samoa and Payments (BoP, current US$) in Ukraine?
Provide a succinct answer. -6.08e+1. In the year 2010, what is the difference between the Payments (BoP, current US$) in Bahamas and Payments (BoP, current US$) in Iraq?
Ensure brevity in your answer.  -4.36e+1. In the year 2010, what is the difference between the Payments (BoP, current US$) in Bahamas and Payments (BoP, current US$) in Samoa?
Keep it short and to the point. 3.66e+09. In the year 2010, what is the difference between the Payments (BoP, current US$) in Bahamas and Payments (BoP, current US$) in Ukraine?
Offer a very short reply. -7.23e+1. In the year 2010, what is the difference between the Payments (BoP, current US$) in Iraq and Payments (BoP, current US$) in Samoa?
Offer a very short reply. 4.73e+1. In the year 2010, what is the difference between the Payments (BoP, current US$) in Iraq and Payments (BoP, current US$) in Ukraine?
Offer a terse response. -2.87e+1. In the year 2010, what is the difference between the Payments (BoP, current US$) in Samoa and Payments (BoP, current US$) in Ukraine?
Provide a succinct answer. -7.59e+1. In the year 2011, what is the difference between the Payments (BoP, current US$) in Bahamas and Payments (BoP, current US$) in Iraq?
Offer a terse response. -4.86e+1. In the year 2011, what is the difference between the Payments (BoP, current US$) of Bahamas and Payments (BoP, current US$) of Samoa?
Ensure brevity in your answer.  4.12e+09. In the year 2011, what is the difference between the Payments (BoP, current US$) in Bahamas and Payments (BoP, current US$) in Ukraine?
Ensure brevity in your answer.  -9.85e+1. In the year 2011, what is the difference between the Payments (BoP, current US$) of Iraq and Payments (BoP, current US$) of Samoa?
Offer a terse response. 5.27e+1. In the year 2011, what is the difference between the Payments (BoP, current US$) in Iraq and Payments (BoP, current US$) in Ukraine?
Your answer should be very brief. -4.99e+1. In the year 2011, what is the difference between the Payments (BoP, current US$) in Samoa and Payments (BoP, current US$) in Ukraine?
Your answer should be very brief. -1.03e+11. What is the ratio of the Payments (BoP, current US$) of Bahamas in 2005 to that in 2006?
Offer a terse response. 0.84. What is the ratio of the Payments (BoP, current US$) in Iraq in 2005 to that in 2006?
Make the answer very short. 1.08. What is the ratio of the Payments (BoP, current US$) in Samoa in 2005 to that in 2006?
Provide a short and direct response. 0.91. What is the ratio of the Payments (BoP, current US$) of Ukraine in 2005 to that in 2006?
Ensure brevity in your answer.  0.8. What is the ratio of the Payments (BoP, current US$) of Bahamas in 2005 to that in 2007?
Give a very brief answer. 0.81. What is the ratio of the Payments (BoP, current US$) in Iraq in 2005 to that in 2007?
Ensure brevity in your answer.  1.18. What is the ratio of the Payments (BoP, current US$) in Samoa in 2005 to that in 2007?
Provide a succinct answer. 0.87. What is the ratio of the Payments (BoP, current US$) of Ukraine in 2005 to that in 2007?
Offer a terse response. 0.59. What is the ratio of the Payments (BoP, current US$) in Bahamas in 2005 to that in 2008?
Provide a succinct answer. 0.82. What is the ratio of the Payments (BoP, current US$) of Iraq in 2005 to that in 2008?
Ensure brevity in your answer.  0.83. What is the ratio of the Payments (BoP, current US$) of Samoa in 2005 to that in 2008?
Make the answer very short. 0.8. What is the ratio of the Payments (BoP, current US$) in Ukraine in 2005 to that in 2008?
Make the answer very short. 0.42. What is the ratio of the Payments (BoP, current US$) in Bahamas in 2005 to that in 2009?
Give a very brief answer. 1. What is the ratio of the Payments (BoP, current US$) of Iraq in 2005 to that in 2009?
Your answer should be very brief. 0.71. What is the ratio of the Payments (BoP, current US$) in Samoa in 2005 to that in 2009?
Ensure brevity in your answer.  0.94. What is the ratio of the Payments (BoP, current US$) of Ukraine in 2005 to that in 2009?
Offer a terse response. 0.72. What is the ratio of the Payments (BoP, current US$) in Bahamas in 2005 to that in 2010?
Give a very brief answer. 0.97. What is the ratio of the Payments (BoP, current US$) in Iraq in 2005 to that in 2010?
Give a very brief answer. 0.66. What is the ratio of the Payments (BoP, current US$) in Samoa in 2005 to that in 2010?
Provide a succinct answer. 0.78. What is the ratio of the Payments (BoP, current US$) of Ukraine in 2005 to that in 2010?
Your answer should be compact. 0.57. What is the ratio of the Payments (BoP, current US$) in Bahamas in 2005 to that in 2011?
Offer a terse response. 0.87. What is the ratio of the Payments (BoP, current US$) in Iraq in 2005 to that in 2011?
Your answer should be very brief. 0.59. What is the ratio of the Payments (BoP, current US$) in Samoa in 2005 to that in 2011?
Give a very brief answer. 0.69. What is the ratio of the Payments (BoP, current US$) in Ukraine in 2005 to that in 2011?
Give a very brief answer. 0.42. What is the ratio of the Payments (BoP, current US$) in Iraq in 2006 to that in 2007?
Your response must be concise. 1.09. What is the ratio of the Payments (BoP, current US$) of Samoa in 2006 to that in 2007?
Your answer should be compact. 0.95. What is the ratio of the Payments (BoP, current US$) of Ukraine in 2006 to that in 2007?
Ensure brevity in your answer.  0.74. What is the ratio of the Payments (BoP, current US$) in Bahamas in 2006 to that in 2008?
Keep it short and to the point. 0.98. What is the ratio of the Payments (BoP, current US$) in Iraq in 2006 to that in 2008?
Your answer should be very brief. 0.76. What is the ratio of the Payments (BoP, current US$) of Samoa in 2006 to that in 2008?
Make the answer very short. 0.87. What is the ratio of the Payments (BoP, current US$) in Ukraine in 2006 to that in 2008?
Make the answer very short. 0.52. What is the ratio of the Payments (BoP, current US$) of Bahamas in 2006 to that in 2009?
Provide a succinct answer. 1.2. What is the ratio of the Payments (BoP, current US$) in Iraq in 2006 to that in 2009?
Make the answer very short. 0.66. What is the ratio of the Payments (BoP, current US$) of Samoa in 2006 to that in 2009?
Make the answer very short. 1.03. What is the ratio of the Payments (BoP, current US$) of Ukraine in 2006 to that in 2009?
Offer a terse response. 0.89. What is the ratio of the Payments (BoP, current US$) in Bahamas in 2006 to that in 2010?
Your response must be concise. 1.17. What is the ratio of the Payments (BoP, current US$) in Iraq in 2006 to that in 2010?
Your answer should be compact. 0.61. What is the ratio of the Payments (BoP, current US$) of Samoa in 2006 to that in 2010?
Offer a very short reply. 0.85. What is the ratio of the Payments (BoP, current US$) in Ukraine in 2006 to that in 2010?
Provide a short and direct response. 0.71. What is the ratio of the Payments (BoP, current US$) in Bahamas in 2006 to that in 2011?
Give a very brief answer. 1.04. What is the ratio of the Payments (BoP, current US$) of Iraq in 2006 to that in 2011?
Give a very brief answer. 0.54. What is the ratio of the Payments (BoP, current US$) of Samoa in 2006 to that in 2011?
Ensure brevity in your answer.  0.76. What is the ratio of the Payments (BoP, current US$) of Ukraine in 2006 to that in 2011?
Your answer should be compact. 0.53. What is the ratio of the Payments (BoP, current US$) of Bahamas in 2007 to that in 2008?
Your response must be concise. 1.02. What is the ratio of the Payments (BoP, current US$) of Iraq in 2007 to that in 2008?
Offer a terse response. 0.7. What is the ratio of the Payments (BoP, current US$) in Samoa in 2007 to that in 2008?
Make the answer very short. 0.91. What is the ratio of the Payments (BoP, current US$) of Ukraine in 2007 to that in 2008?
Your answer should be compact. 0.71. What is the ratio of the Payments (BoP, current US$) of Bahamas in 2007 to that in 2009?
Keep it short and to the point. 1.24. What is the ratio of the Payments (BoP, current US$) of Iraq in 2007 to that in 2009?
Provide a succinct answer. 0.6. What is the ratio of the Payments (BoP, current US$) in Samoa in 2007 to that in 2009?
Ensure brevity in your answer.  1.08. What is the ratio of the Payments (BoP, current US$) in Ukraine in 2007 to that in 2009?
Make the answer very short. 1.21. What is the ratio of the Payments (BoP, current US$) in Bahamas in 2007 to that in 2010?
Your answer should be compact. 1.21. What is the ratio of the Payments (BoP, current US$) of Iraq in 2007 to that in 2010?
Offer a very short reply. 0.56. What is the ratio of the Payments (BoP, current US$) in Samoa in 2007 to that in 2010?
Offer a terse response. 0.89. What is the ratio of the Payments (BoP, current US$) of Ukraine in 2007 to that in 2010?
Offer a very short reply. 0.97. What is the ratio of the Payments (BoP, current US$) in Bahamas in 2007 to that in 2011?
Provide a succinct answer. 1.07. What is the ratio of the Payments (BoP, current US$) in Iraq in 2007 to that in 2011?
Ensure brevity in your answer.  0.5. What is the ratio of the Payments (BoP, current US$) of Samoa in 2007 to that in 2011?
Keep it short and to the point. 0.79. What is the ratio of the Payments (BoP, current US$) in Ukraine in 2007 to that in 2011?
Ensure brevity in your answer.  0.72. What is the ratio of the Payments (BoP, current US$) in Bahamas in 2008 to that in 2009?
Your answer should be very brief. 1.22. What is the ratio of the Payments (BoP, current US$) in Iraq in 2008 to that in 2009?
Offer a terse response. 0.86. What is the ratio of the Payments (BoP, current US$) in Samoa in 2008 to that in 2009?
Your answer should be very brief. 1.18. What is the ratio of the Payments (BoP, current US$) of Ukraine in 2008 to that in 2009?
Your answer should be very brief. 1.7. What is the ratio of the Payments (BoP, current US$) in Bahamas in 2008 to that in 2010?
Your answer should be compact. 1.19. What is the ratio of the Payments (BoP, current US$) in Iraq in 2008 to that in 2010?
Keep it short and to the point. 0.79. What is the ratio of the Payments (BoP, current US$) in Samoa in 2008 to that in 2010?
Give a very brief answer. 0.98. What is the ratio of the Payments (BoP, current US$) in Ukraine in 2008 to that in 2010?
Offer a very short reply. 1.36. What is the ratio of the Payments (BoP, current US$) in Bahamas in 2008 to that in 2011?
Your response must be concise. 1.06. What is the ratio of the Payments (BoP, current US$) in Iraq in 2008 to that in 2011?
Offer a terse response. 0.71. What is the ratio of the Payments (BoP, current US$) of Samoa in 2008 to that in 2011?
Your response must be concise. 0.87. What is the ratio of the Payments (BoP, current US$) of Ukraine in 2008 to that in 2011?
Provide a short and direct response. 1.01. What is the ratio of the Payments (BoP, current US$) in Bahamas in 2009 to that in 2010?
Your answer should be very brief. 0.97. What is the ratio of the Payments (BoP, current US$) of Iraq in 2009 to that in 2010?
Provide a short and direct response. 0.93. What is the ratio of the Payments (BoP, current US$) in Samoa in 2009 to that in 2010?
Make the answer very short. 0.83. What is the ratio of the Payments (BoP, current US$) of Ukraine in 2009 to that in 2010?
Your response must be concise. 0.8. What is the ratio of the Payments (BoP, current US$) in Bahamas in 2009 to that in 2011?
Make the answer very short. 0.87. What is the ratio of the Payments (BoP, current US$) of Iraq in 2009 to that in 2011?
Keep it short and to the point. 0.83. What is the ratio of the Payments (BoP, current US$) in Samoa in 2009 to that in 2011?
Your answer should be very brief. 0.74. What is the ratio of the Payments (BoP, current US$) of Ukraine in 2009 to that in 2011?
Your response must be concise. 0.59. What is the ratio of the Payments (BoP, current US$) in Bahamas in 2010 to that in 2011?
Your response must be concise. 0.89. What is the ratio of the Payments (BoP, current US$) of Iraq in 2010 to that in 2011?
Keep it short and to the point. 0.9. What is the ratio of the Payments (BoP, current US$) in Samoa in 2010 to that in 2011?
Give a very brief answer. 0.89. What is the ratio of the Payments (BoP, current US$) of Ukraine in 2010 to that in 2011?
Your response must be concise. 0.74. What is the difference between the highest and the second highest Payments (BoP, current US$) of Bahamas?
Offer a very short reply. 8.88e+07. What is the difference between the highest and the second highest Payments (BoP, current US$) of Iraq?
Your answer should be compact. 5.49e+09. What is the difference between the highest and the second highest Payments (BoP, current US$) in Samoa?
Offer a very short reply. 4.78e+07. What is the difference between the highest and the second highest Payments (BoP, current US$) of Ukraine?
Your answer should be compact. 7.29e+08. What is the difference between the highest and the lowest Payments (BoP, current US$) of Bahamas?
Provide a short and direct response. 9.48e+08. What is the difference between the highest and the lowest Payments (BoP, current US$) of Iraq?
Offer a terse response. 2.67e+1. What is the difference between the highest and the lowest Payments (BoP, current US$) of Samoa?
Your answer should be compact. 1.34e+08. What is the difference between the highest and the lowest Payments (BoP, current US$) of Ukraine?
Ensure brevity in your answer.  6.01e+1. 